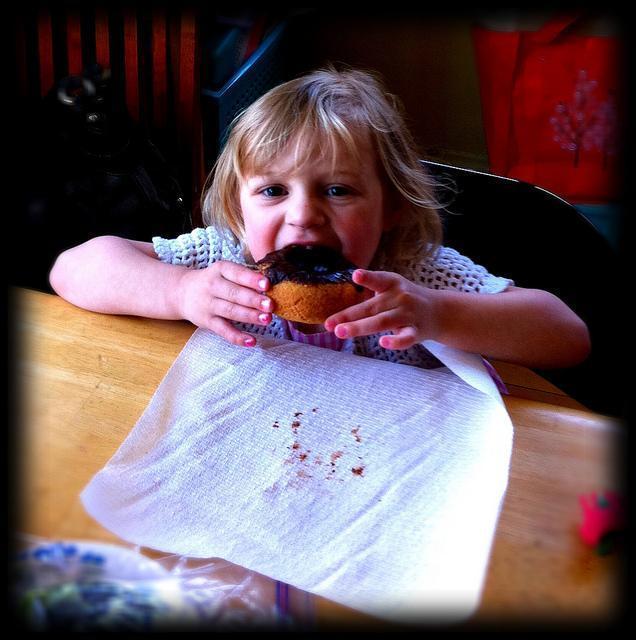Verify the accuracy of this image caption: "The donut is touching the dining table.".
Answer yes or no. No. 